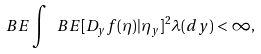<formula> <loc_0><loc_0><loc_500><loc_500>\ B E \int \ B E [ D _ { y } f ( \eta ) | \eta _ { y } ] ^ { 2 } \lambda ( d y ) < \infty ,</formula> 